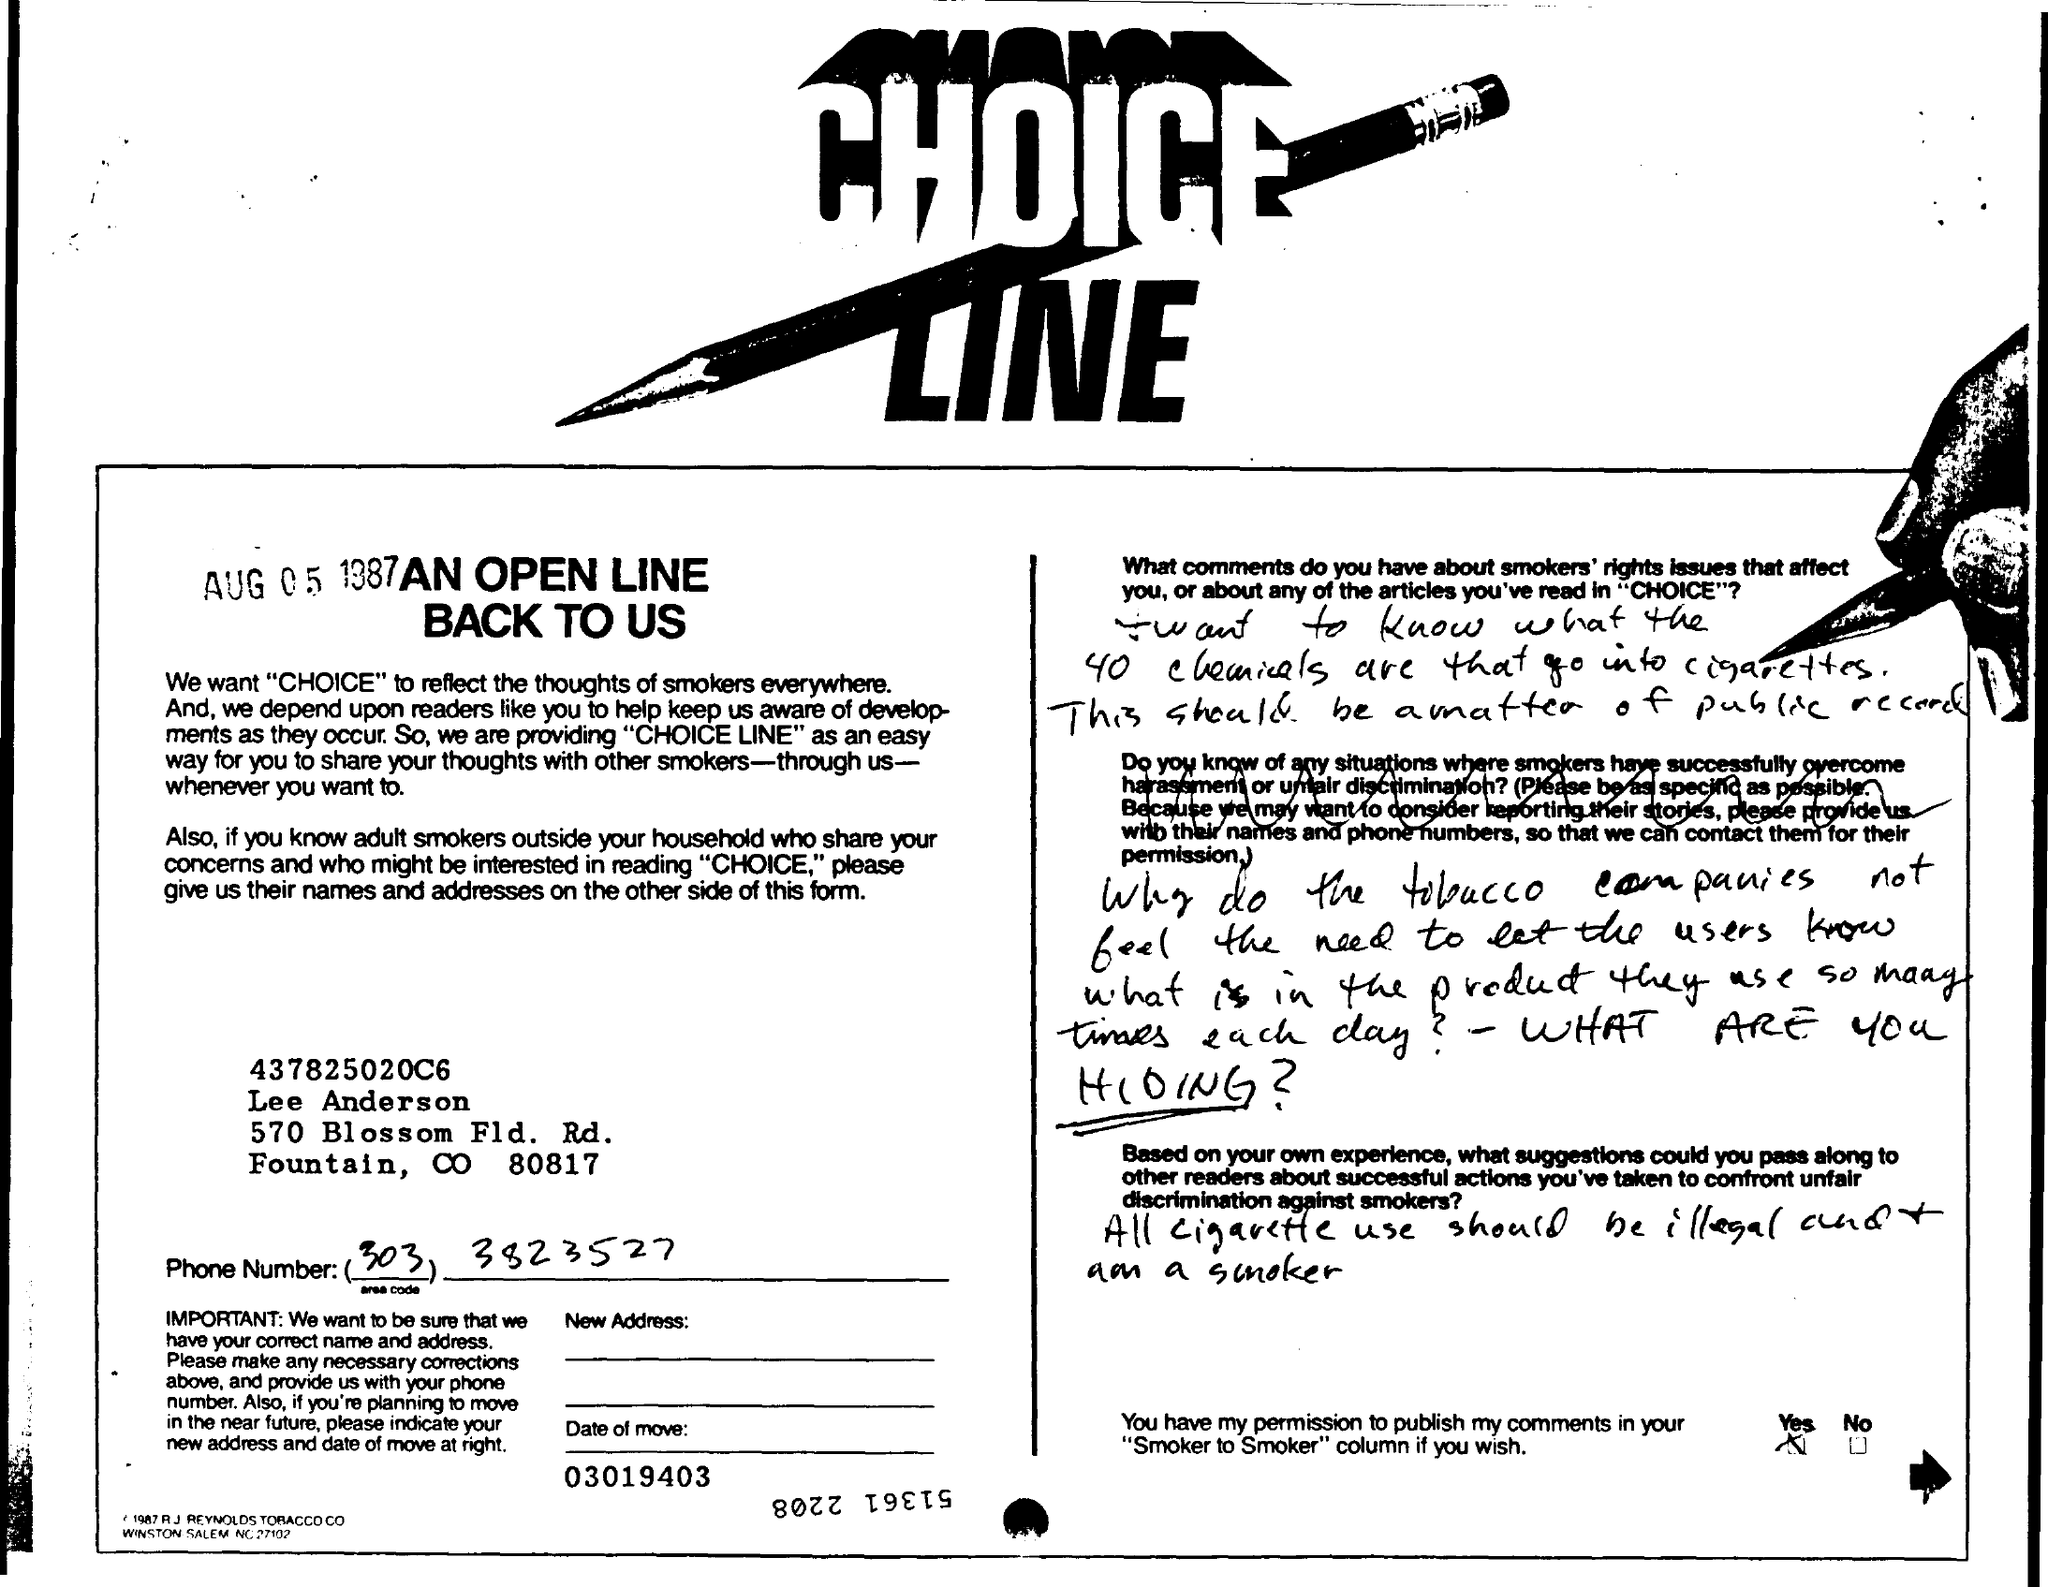What is the Title of the document?
Offer a terse response. Choice Line. What is the date on the document?
Provide a succinct answer. AUG 05 1987. 